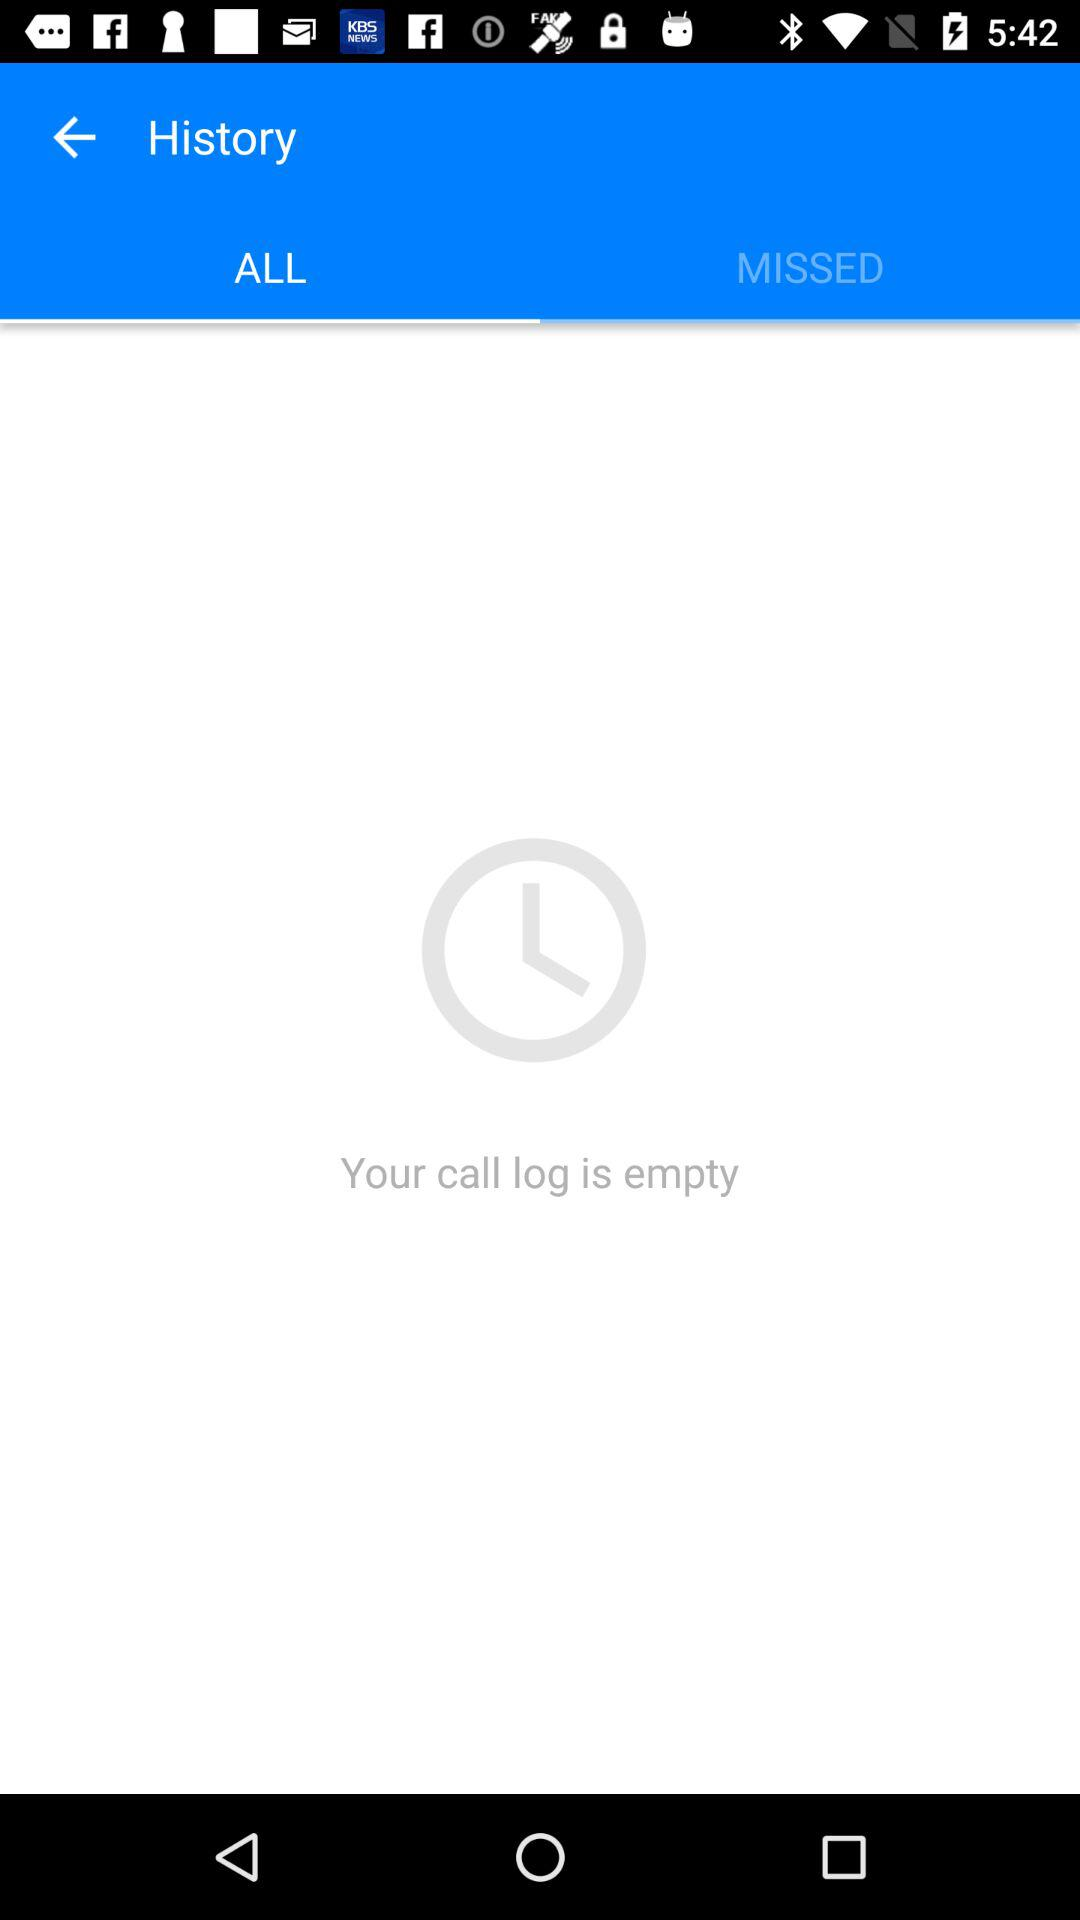Which tab is selected? The selected tab is "ALL". 